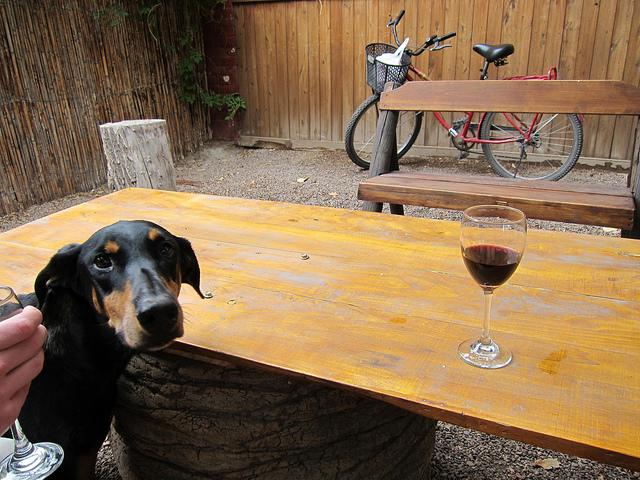What color is the bicycle?
Give a very brief answer. Red. Is the dog drinking wine?
Give a very brief answer. No. What animal is shown?
Write a very short answer. Dog. 